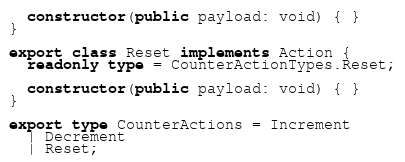<code> <loc_0><loc_0><loc_500><loc_500><_TypeScript_>  constructor(public payload: void) { }
}

export class Reset implements Action {
  readonly type = CounterActionTypes.Reset;

  constructor(public payload: void) { }
}

export type CounterActions = Increment
  | Decrement
  | Reset;
</code> 